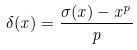Convert formula to latex. <formula><loc_0><loc_0><loc_500><loc_500>\delta ( x ) = \frac { \sigma ( x ) - x ^ { p } } { p }</formula> 